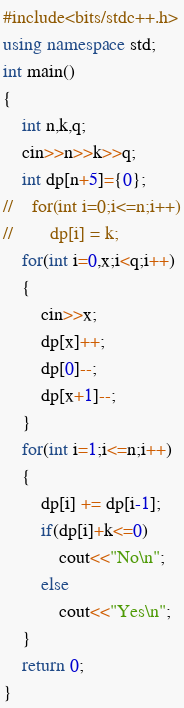<code> <loc_0><loc_0><loc_500><loc_500><_C++_>#include<bits/stdc++.h>
using namespace std;
int main()
{
    int n,k,q;
    cin>>n>>k>>q;
    int dp[n+5]={0};
//    for(int i=0;i<=n;i++)
//        dp[i] = k;
    for(int i=0,x;i<q;i++)
    {
        cin>>x;
        dp[x]++;
        dp[0]--;
        dp[x+1]--;
    }
    for(int i=1;i<=n;i++)
    {
        dp[i] += dp[i-1];
        if(dp[i]+k<=0)
            cout<<"No\n";
        else
            cout<<"Yes\n";
    }
    return 0;
}
</code> 